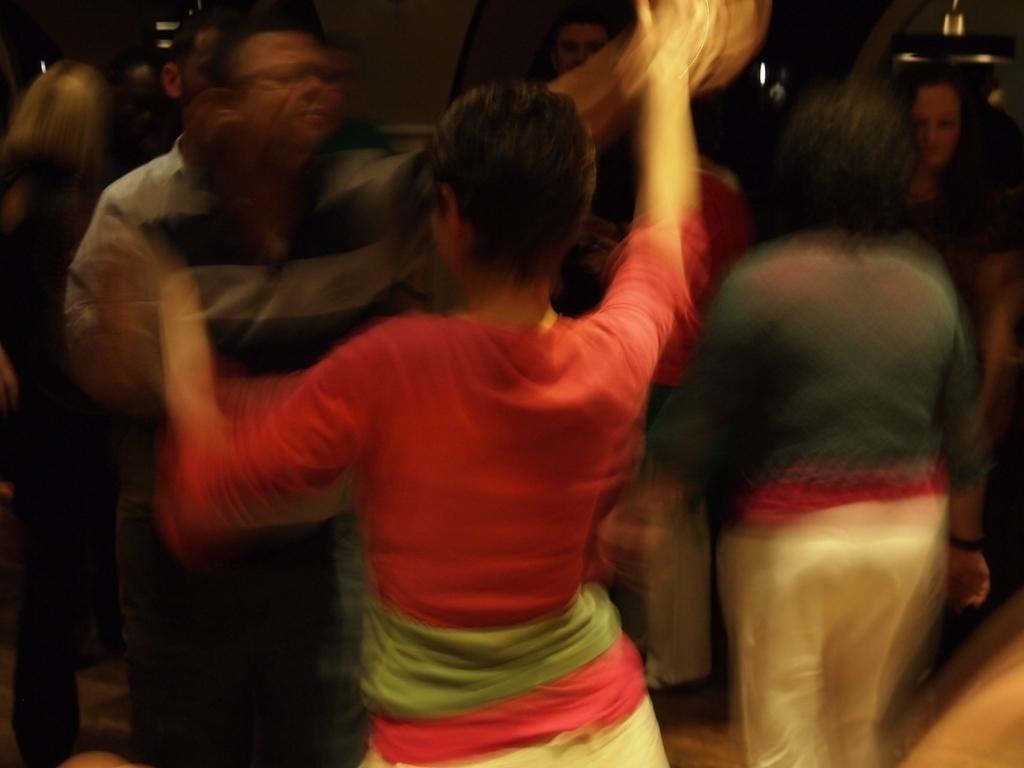How many individuals are present in the image? There is a group of people in the image, but the exact number cannot be determined without more information. Can you describe the group of people in the image? Unfortunately, the provided facts do not give any details about the group of people, so it is impossible to describe them. What type of pies are the squirrels eating while crying in the image? There are no squirrels, pies, or crying in the image; it only contains a group of people. 